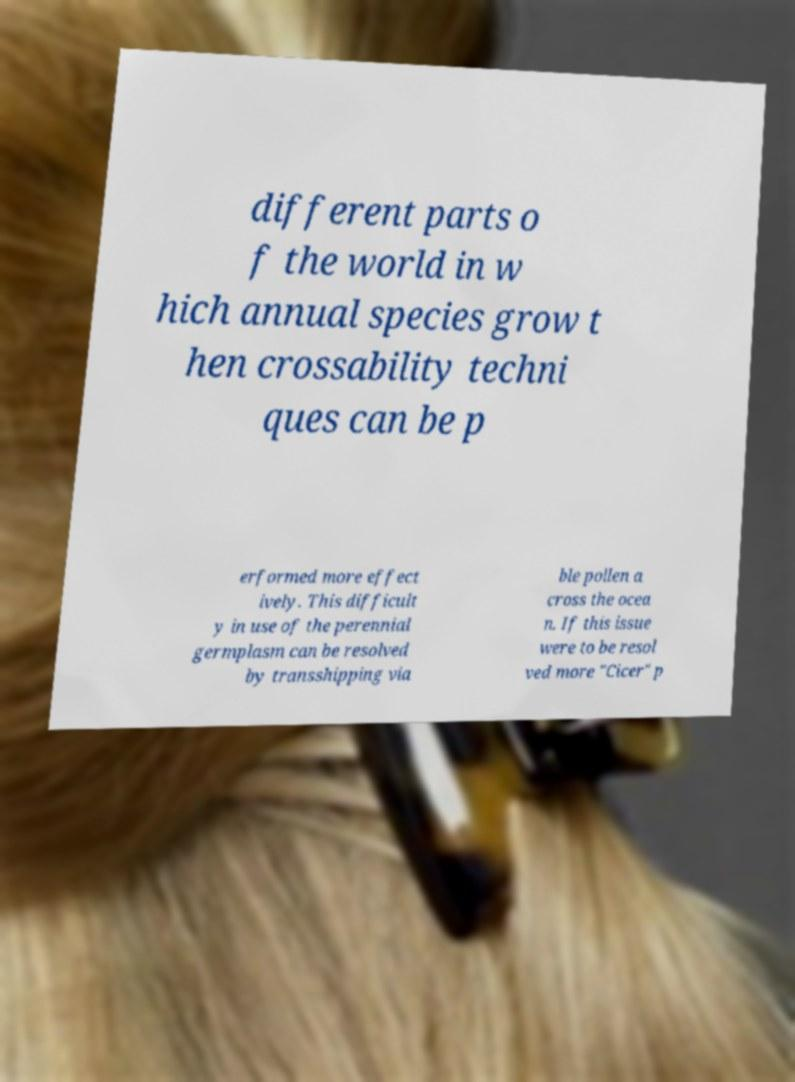What messages or text are displayed in this image? I need them in a readable, typed format. different parts o f the world in w hich annual species grow t hen crossability techni ques can be p erformed more effect ively. This difficult y in use of the perennial germplasm can be resolved by transshipping via ble pollen a cross the ocea n. If this issue were to be resol ved more "Cicer" p 